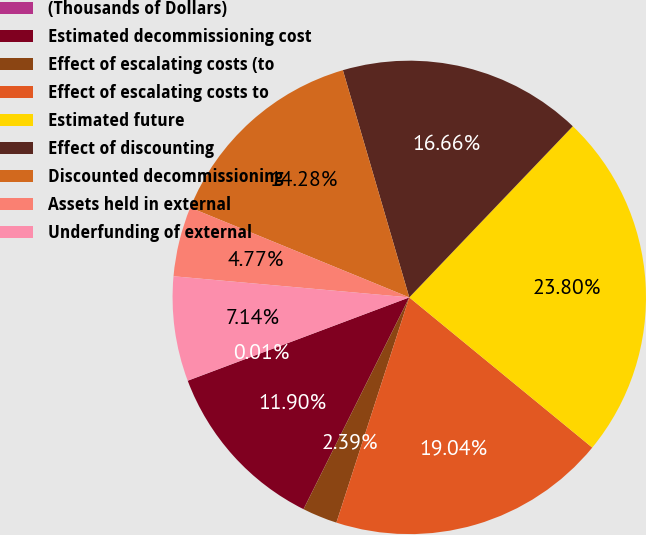Convert chart. <chart><loc_0><loc_0><loc_500><loc_500><pie_chart><fcel>(Thousands of Dollars)<fcel>Estimated decommissioning cost<fcel>Effect of escalating costs (to<fcel>Effect of escalating costs to<fcel>Estimated future<fcel>Effect of discounting<fcel>Discounted decommissioning<fcel>Assets held in external<fcel>Underfunding of external<nl><fcel>0.01%<fcel>11.9%<fcel>2.39%<fcel>19.04%<fcel>23.8%<fcel>16.66%<fcel>14.28%<fcel>4.77%<fcel>7.14%<nl></chart> 